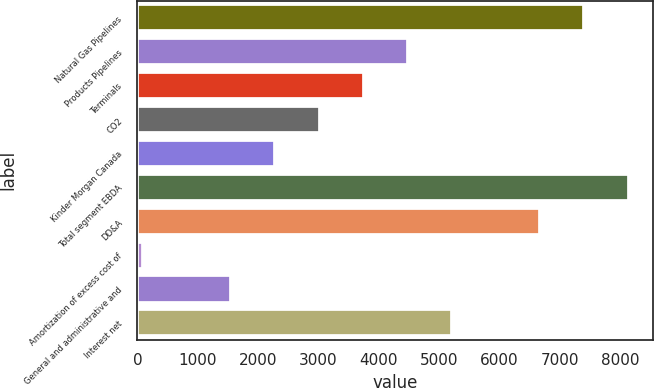Convert chart. <chart><loc_0><loc_0><loc_500><loc_500><bar_chart><fcel>Natural Gas Pipelines<fcel>Products Pipelines<fcel>Terminals<fcel>CO2<fcel>Kinder Morgan Canada<fcel>Total segment EBDA<fcel>DD&A<fcel>Amortization of excess cost of<fcel>General and administrative and<fcel>Interest net<nl><fcel>7403<fcel>4479.8<fcel>3749<fcel>3018.2<fcel>2287.4<fcel>8133.8<fcel>6672.2<fcel>95<fcel>1556.6<fcel>5210.6<nl></chart> 